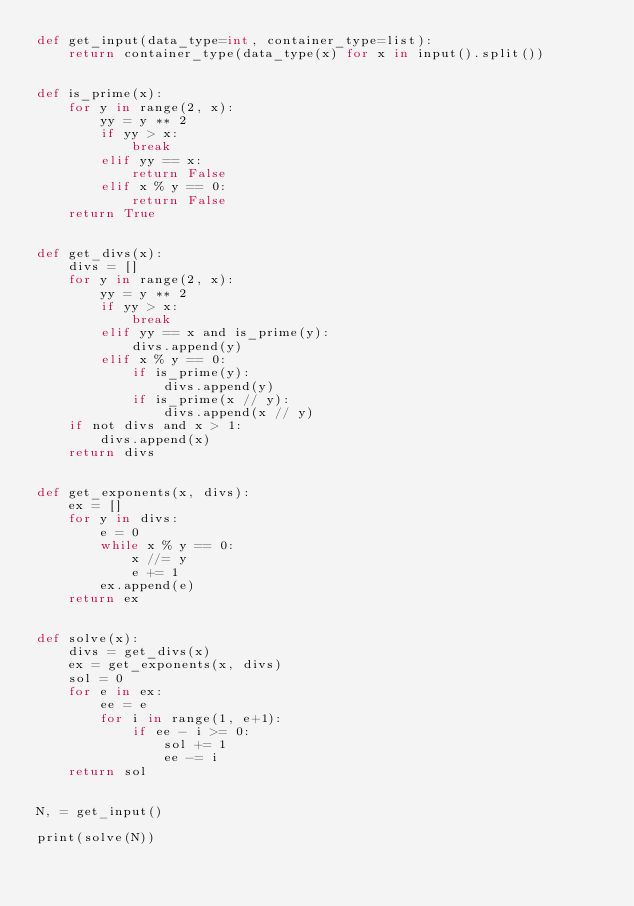<code> <loc_0><loc_0><loc_500><loc_500><_Cython_>def get_input(data_type=int, container_type=list):
    return container_type(data_type(x) for x in input().split())


def is_prime(x):
    for y in range(2, x):
        yy = y ** 2
        if yy > x:
            break
        elif yy == x:
            return False
        elif x % y == 0:
            return False
    return True


def get_divs(x):
    divs = []
    for y in range(2, x):
        yy = y ** 2
        if yy > x:
            break
        elif yy == x and is_prime(y):
            divs.append(y)
        elif x % y == 0:
            if is_prime(y):
                divs.append(y)
            if is_prime(x // y):
                divs.append(x // y)
    if not divs and x > 1:
        divs.append(x)
    return divs


def get_exponents(x, divs):
    ex = []
    for y in divs:
        e = 0
        while x % y == 0:
            x //= y
            e += 1
        ex.append(e)
    return ex


def solve(x):
    divs = get_divs(x)
    ex = get_exponents(x, divs)
    sol = 0
    for e in ex:
        ee = e
        for i in range(1, e+1):
            if ee - i >= 0:
                sol += 1
                ee -= i
    return sol


N, = get_input()

print(solve(N))
</code> 